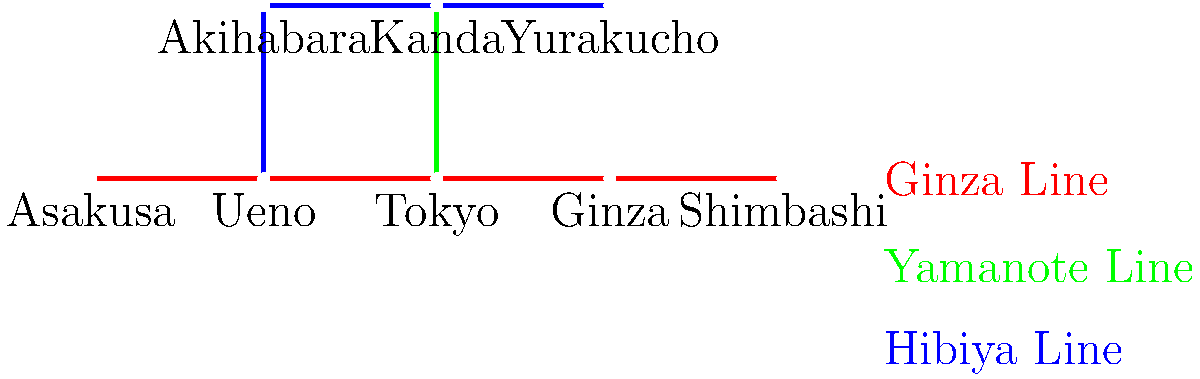You're planning a day trip to visit historical sites in Tokyo. You want to start at Asakusa (famous for Senso-ji Temple) and end at Shimbashi (near Tokyo Tower). What is the most efficient route using the subway lines shown in the map, and how many transfers will you need to make? Let's break down the most efficient route from Asakusa to Shimbashi:

1. Start at Asakusa station on the Ginza Line (red).
2. Take the Ginza Line directly to Shimbashi station.

This route is the most efficient because:

a) It uses only one line (Ginza Line) for the entire journey.
b) It doesn't require any transfers.
c) It's a straight path on the map, indicating the shortest distance.

Alternative routes would require transfers and likely take longer:
- Taking the Ginza Line to Ueno, then transferring to the Yamanote Line (green) would be longer and require a transfer.
- Any route involving the Hibiya Line (blue) would require at least one transfer and wouldn't be as direct.

The Ginza Line connects Asakusa and Shimbashi directly, making it the optimal choice for this journey.

Number of transfers: 0
Answer: Take Ginza Line directly from Asakusa to Shimbashi; 0 transfers. 